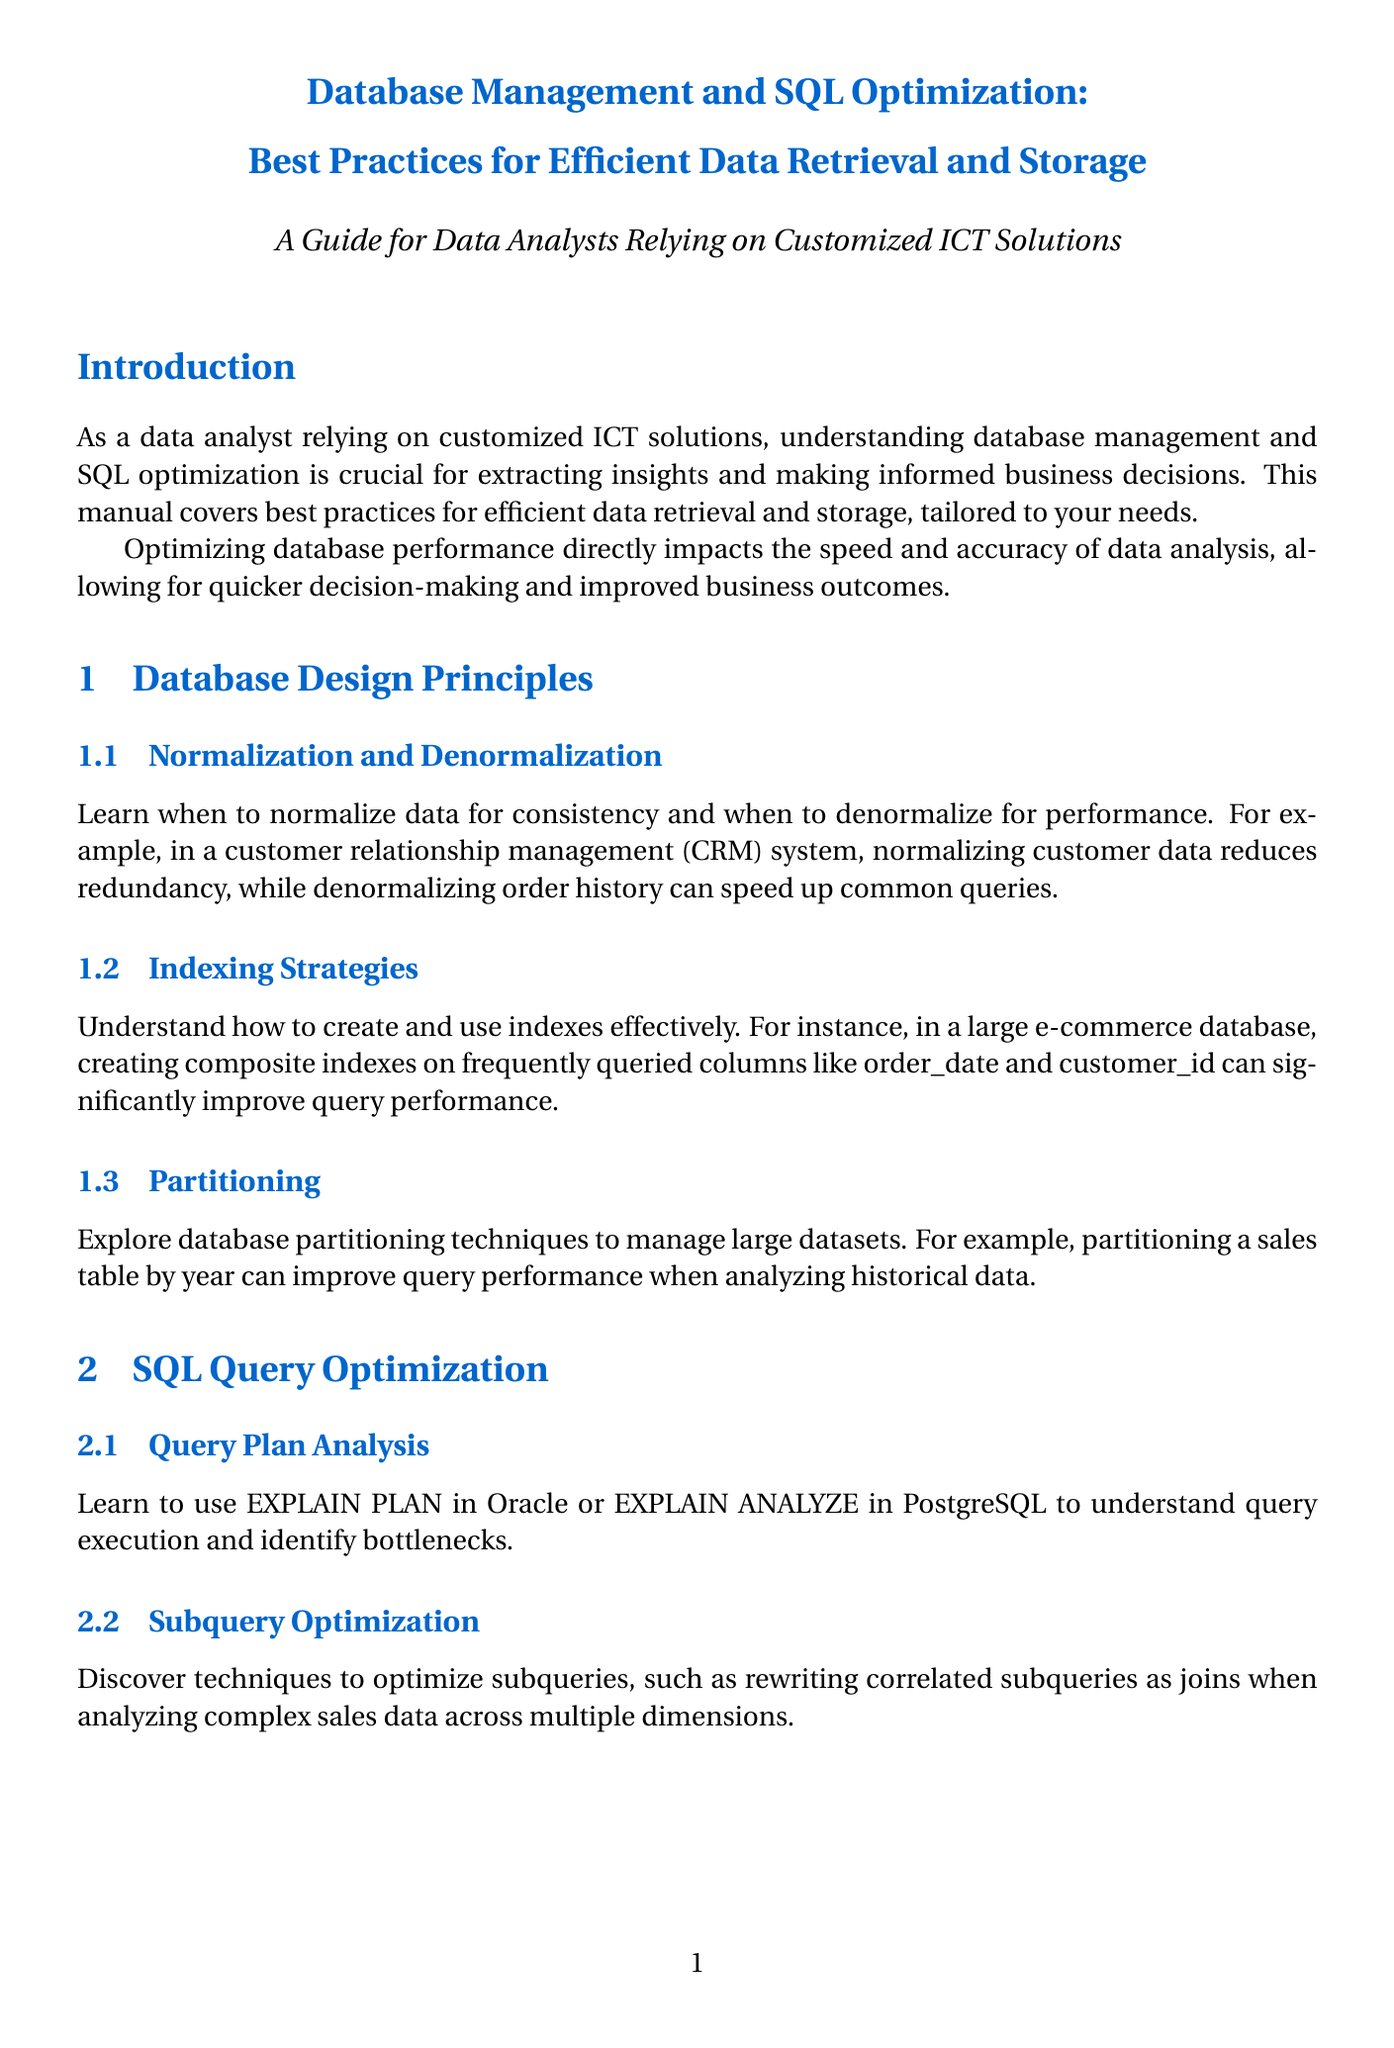what is the title of the manual? The title of the manual is mentioned at the beginning as "Database Management and SQL Optimization: Best Practices for Efficient Data Retrieval and Storage."
Answer: Database Management and SQL Optimization: Best Practices for Efficient Data Retrieval and Storage what are the key learnings from the case study on optimizing a data warehouse? The key learnings are listed under the case study section discussing the retail company, focusing on techniques implemented to improve BI reporting speed.
Answer: Implementing columnstore indexes for analytical queries, Using partitioned views to manage historical data, Optimizing ETL processes for faster data loading what is the importance of SQL optimization mentioned in the introduction? The importance is highlighted as directly impacting the speed and accuracy of data analysis, which leads to quicker decision-making.
Answer: Speed and accuracy of data analysis which SQL command is suggested for query plan analysis? The manual suggests using the EXPLAIN PLAN in Oracle or EXPLAIN ANALYZE in PostgreSQL for query plan analysis.
Answer: EXPLAIN PLAN / EXPLAIN ANALYZE what technique can be used to improve the efficiency of large result sets? The document suggests implementing pagination using OFFSET and LIMIT in MySQL or ROW_NUMBER() in SQL Server.
Answer: Pagination using OFFSET and LIMIT what should be selected to optimize storage in data storage optimization? The manual states that appropriate data types should be selected for columns to optimize storage and query performance.
Answer: Appropriate data types what database technique is mentioned for managing datasets in the section on partitioning? The manual discusses partitioning techniques to manage large datasets, specifically partitioning a sales table by year.
Answer: Partitioning a sales table by year which section discusses identifying and optimizing slow queries? The section that addresses this topic is "Identifying Slow Queries" under the "Performance Monitoring and Tuning" chapter.
Answer: Identifying Slow Queries 